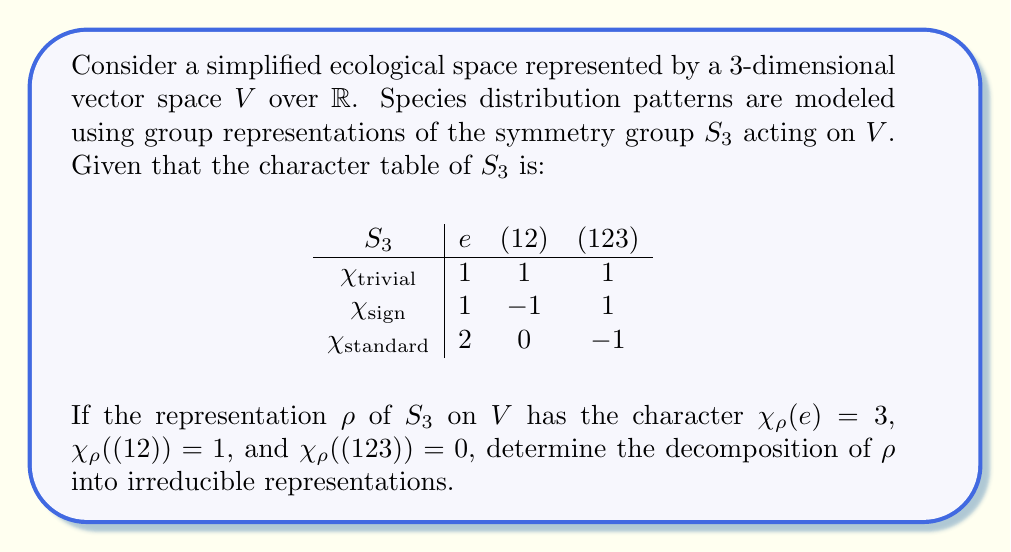Can you solve this math problem? To solve this problem, we'll follow these steps:

1) First, we need to express $\chi_\rho$ as a linear combination of the irreducible characters:

   $\chi_\rho = a\chi_{\text{trivial}} + b\chi_{\text{sign}} + c\chi_{\text{standard}}$

2) We can determine the coefficients $a$, $b$, and $c$ using the inner product of characters:

   $a = \frac{1}{|S_3|}\sum_{g \in S_3} \chi_\rho(g)\overline{\chi_{\text{trivial}}(g)}$
   $b = \frac{1}{|S_3|}\sum_{g \in S_3} \chi_\rho(g)\overline{\chi_{\text{sign}}(g)}$
   $c = \frac{1}{|S_3|}\sum_{g \in S_3} \chi_\rho(g)\overline{\chi_{\text{standard}}(g)}$

3) Calculate $a$:
   $a = \frac{1}{6}(3 \cdot 1 + 3 \cdot 1 + 1 \cdot 1 + 0 \cdot 1) = \frac{7}{6}$

4) Calculate $b$:
   $b = \frac{1}{6}(3 \cdot 1 + 3 \cdot 1 - 1 \cdot 1 + 0 \cdot 1) = \frac{5}{6}$

5) Calculate $c$:
   $c = \frac{1}{6}(3 \cdot 2 + 3 \cdot 0 + 1 \cdot 0 + 0 \cdot (-1)) = 1$

6) Therefore, the decomposition of $\rho$ is:

   $\rho \cong 1\chi_{\text{trivial}} \oplus 1\chi_{\text{sign}} \oplus 1\chi_{\text{standard}}$

This decomposition indicates that in our ecological space, species distribution patterns exhibit a combination of symmetric, antisymmetric, and mixed behaviors under permutations of environmental variables.
Answer: $\rho \cong \chi_{\text{trivial}} \oplus \chi_{\text{sign}} \oplus \chi_{\text{standard}}$ 